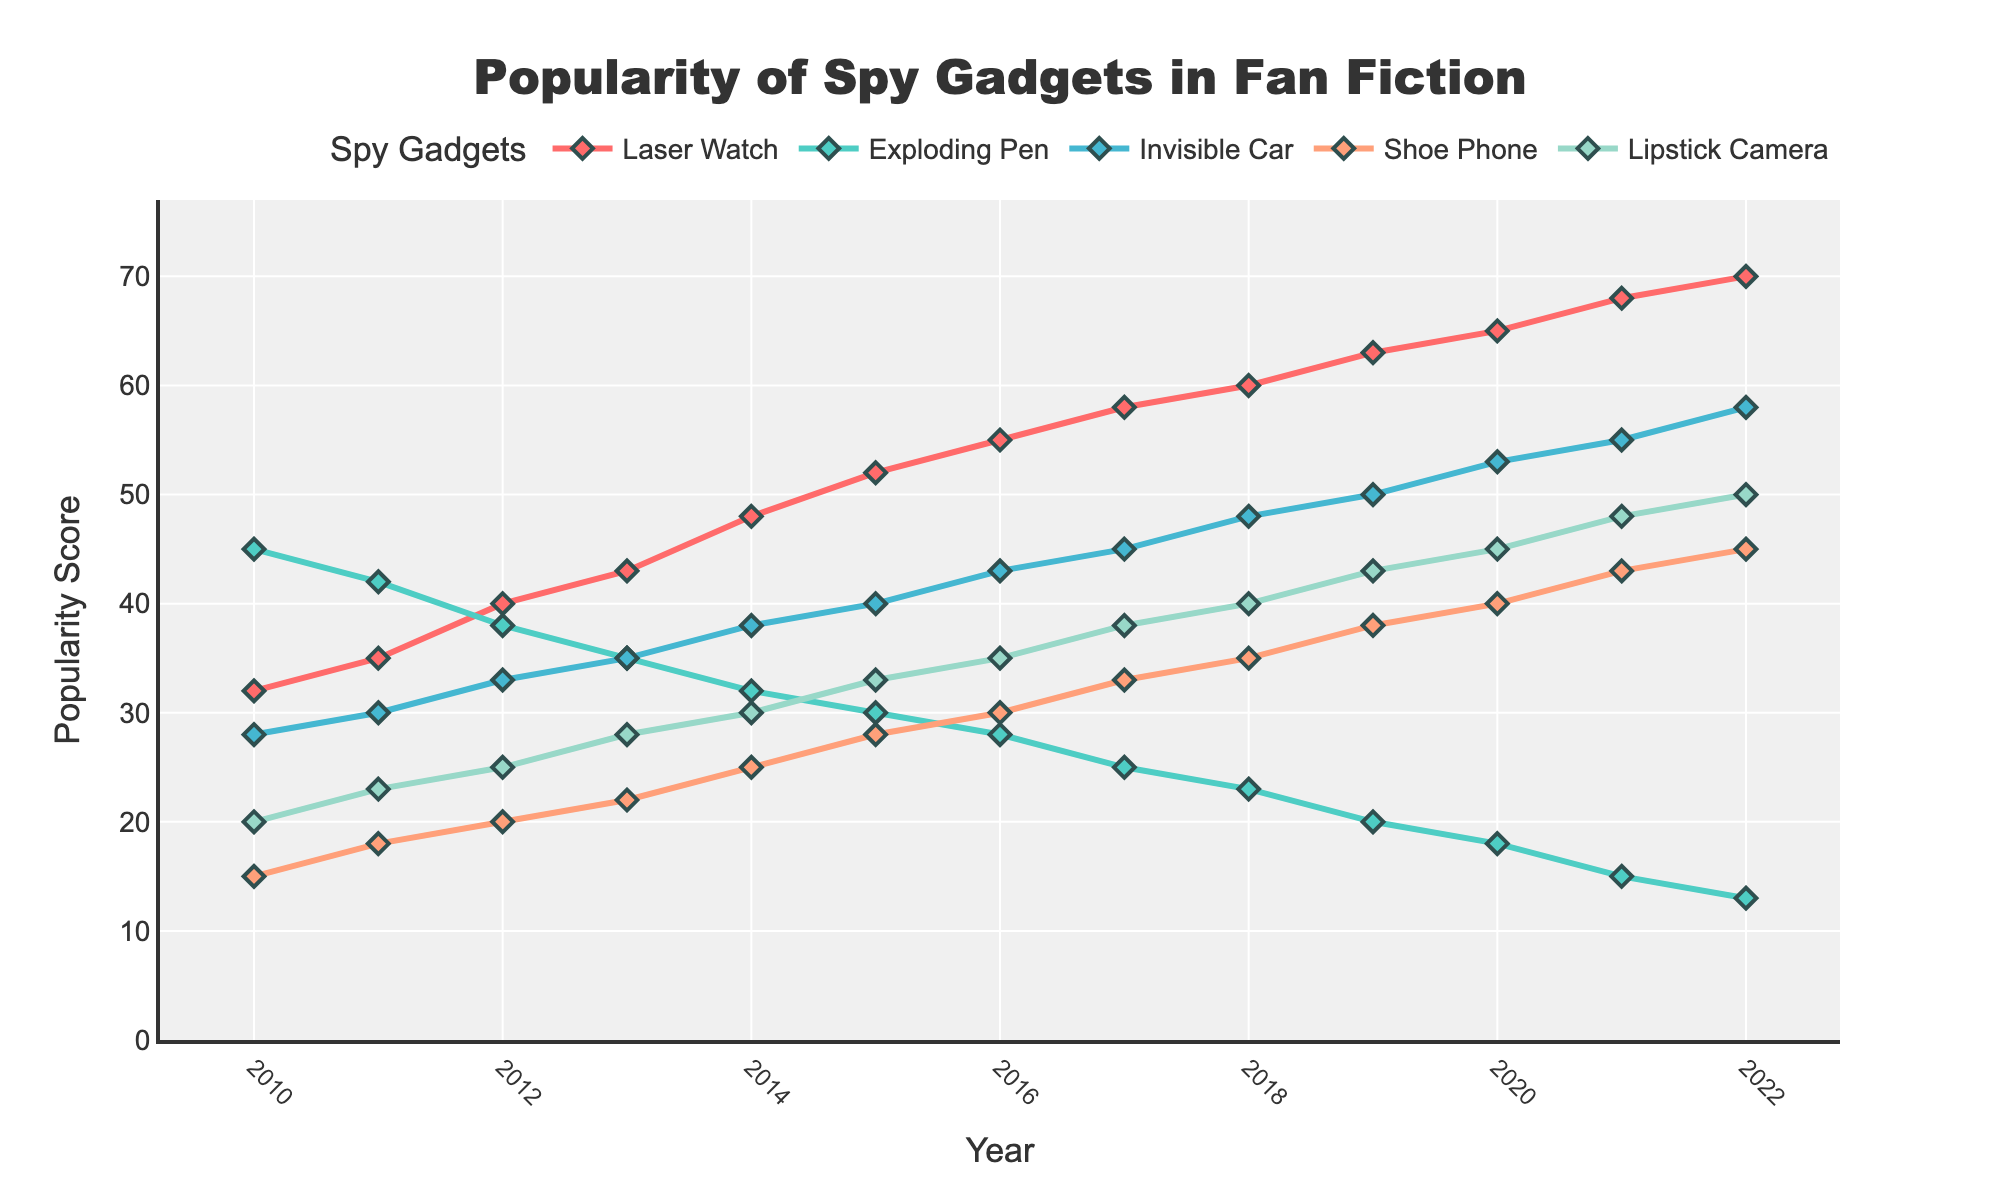What is the overall trend in the popularity of the Exploding Pen from 2010 to 2022? The popularity of the Exploding Pen generally decreases over the years. In 2010, it starts at 45 and drops to 13 by 2022.
Answer: Decreasing Which gadget has the highest popularity score in 2022? In 2022, the Laser Watch has the highest popularity score of 70.
Answer: Laser Watch How much did the popularity of the Invisible Car increase from 2010 to 2022? The popularity of the Invisible Car in 2010 is 28, and it rises to 58 in 2022. The increase is 58 - 28 = 30.
Answer: 30 Comparing the Lipstick Camera and the Shoe Phone, which had a higher popularity score in 2020, and what were the scores? In 2020, the Lipstick Camera has a higher popularity score of 45 compared to the Shoe Phone's score of 40.
Answer: Lipstick Camera, 45; Shoe Phone, 40 What is the average popularity of the Laser Watch from 2010 to 2022? The popularity scores of the Laser Watch from 2010 to 2022 are 32, 35, 40, 43, 48, 52, 55, 58, 60, 63, 65, 68, and 70. The sum of these scores is 689. The number of years is 13, so the average is 689 / 13 ≈ 53.
Answer: 53 In which year did the Lipstick Camera surpass the popularity score of 35 for the first time? The Lipstick Camera first surpasses the popularity score of 35 in 2017 with a score of 38.
Answer: 2017 Which gadget shows the most significant increase in popularity from 2010 to 2022? The Laser Watch shows the most significant increase in popularity, rising from 32 in 2010 to 70 in 2022, an increase of 38 points.
Answer: Laser Watch During which years did the popularity score of the Shoe Phone stay below 20? The popularity score of the Shoe Phone stayed below 20 only in the year 2010 with a score of 15.
Answer: 2010 If we consider the years 2010, 2014, 2018, and 2022, which gadget experienced the largest increase in popularity during these years? The Laser Watch in 2010 (32), 2014 (48), 2018 (60), and 2022 (70) shows the largest increase from 32 in 2010 to 70 in 2022, which is an increase of 38 points.
Answer: Laser Watch Which two gadgets had their popularity scores closest to each other in 2016? In 2016, the popularity scores are: Laser Watch (55), Exploding Pen (28), Invisible Car (43), Shoe Phone (30), Lipstick Camera (35). The scores closest to each other are Shoe Phone and Lipstick Camera, with scores of 30 and 35, respectively, a difference of 5 points.
Answer: Shoe Phone and Lipstick Camera 